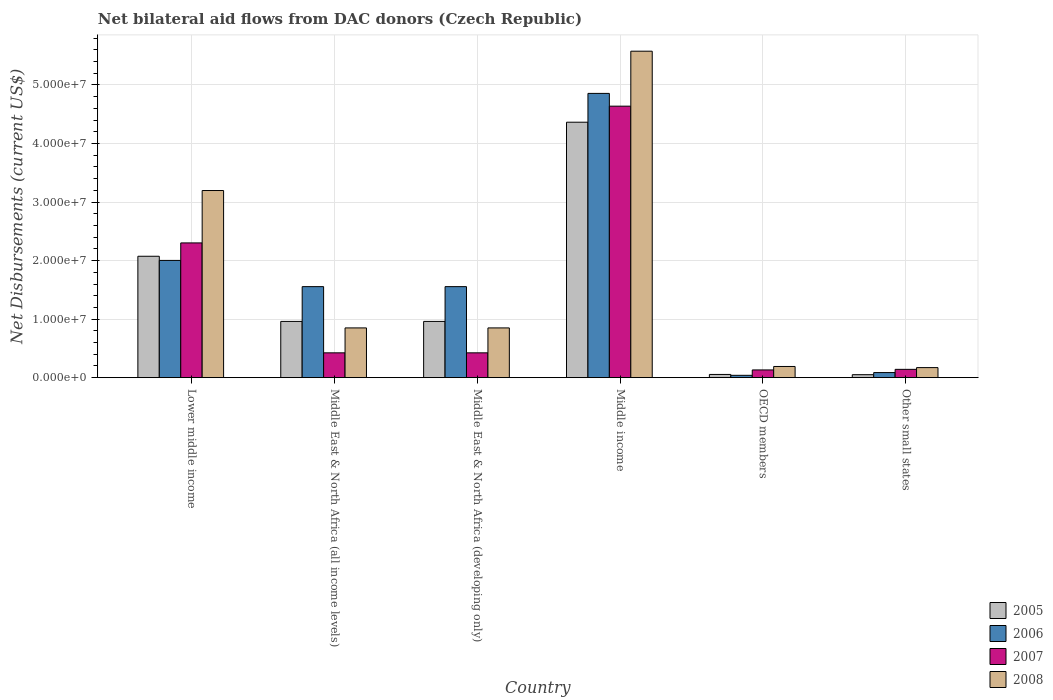How many different coloured bars are there?
Provide a succinct answer. 4. Are the number of bars per tick equal to the number of legend labels?
Your answer should be compact. Yes. Are the number of bars on each tick of the X-axis equal?
Make the answer very short. Yes. How many bars are there on the 5th tick from the right?
Offer a very short reply. 4. What is the label of the 2nd group of bars from the left?
Your response must be concise. Middle East & North Africa (all income levels). In how many cases, is the number of bars for a given country not equal to the number of legend labels?
Offer a very short reply. 0. What is the net bilateral aid flows in 2008 in Lower middle income?
Give a very brief answer. 3.20e+07. Across all countries, what is the maximum net bilateral aid flows in 2008?
Provide a succinct answer. 5.58e+07. Across all countries, what is the minimum net bilateral aid flows in 2006?
Your answer should be compact. 4.00e+05. In which country was the net bilateral aid flows in 2007 maximum?
Keep it short and to the point. Middle income. In which country was the net bilateral aid flows in 2007 minimum?
Give a very brief answer. OECD members. What is the total net bilateral aid flows in 2008 in the graph?
Your response must be concise. 1.08e+08. What is the difference between the net bilateral aid flows in 2007 in Middle East & North Africa (all income levels) and that in Middle East & North Africa (developing only)?
Keep it short and to the point. 0. What is the difference between the net bilateral aid flows in 2005 in Middle East & North Africa (all income levels) and the net bilateral aid flows in 2008 in Lower middle income?
Your response must be concise. -2.24e+07. What is the average net bilateral aid flows in 2005 per country?
Provide a succinct answer. 1.41e+07. What is the difference between the net bilateral aid flows of/in 2008 and net bilateral aid flows of/in 2005 in OECD members?
Provide a short and direct response. 1.36e+06. What is the ratio of the net bilateral aid flows in 2005 in Lower middle income to that in OECD members?
Your answer should be very brief. 37.71. Is the net bilateral aid flows in 2007 in Middle East & North Africa (all income levels) less than that in OECD members?
Your answer should be compact. No. Is the difference between the net bilateral aid flows in 2008 in Lower middle income and Middle East & North Africa (developing only) greater than the difference between the net bilateral aid flows in 2005 in Lower middle income and Middle East & North Africa (developing only)?
Offer a very short reply. Yes. What is the difference between the highest and the second highest net bilateral aid flows in 2008?
Ensure brevity in your answer.  4.73e+07. What is the difference between the highest and the lowest net bilateral aid flows in 2008?
Your answer should be very brief. 5.40e+07. In how many countries, is the net bilateral aid flows in 2005 greater than the average net bilateral aid flows in 2005 taken over all countries?
Provide a succinct answer. 2. Is it the case that in every country, the sum of the net bilateral aid flows in 2006 and net bilateral aid flows in 2007 is greater than the sum of net bilateral aid flows in 2008 and net bilateral aid flows in 2005?
Offer a very short reply. No. What does the 1st bar from the right in Lower middle income represents?
Offer a very short reply. 2008. Is it the case that in every country, the sum of the net bilateral aid flows in 2005 and net bilateral aid flows in 2007 is greater than the net bilateral aid flows in 2006?
Keep it short and to the point. No. Are all the bars in the graph horizontal?
Provide a short and direct response. No. How many countries are there in the graph?
Ensure brevity in your answer.  6. What is the difference between two consecutive major ticks on the Y-axis?
Ensure brevity in your answer.  1.00e+07. Are the values on the major ticks of Y-axis written in scientific E-notation?
Your response must be concise. Yes. Does the graph contain any zero values?
Offer a terse response. No. Does the graph contain grids?
Keep it short and to the point. Yes. Where does the legend appear in the graph?
Keep it short and to the point. Bottom right. How many legend labels are there?
Provide a short and direct response. 4. How are the legend labels stacked?
Your answer should be very brief. Vertical. What is the title of the graph?
Your answer should be very brief. Net bilateral aid flows from DAC donors (Czech Republic). Does "1996" appear as one of the legend labels in the graph?
Your answer should be compact. No. What is the label or title of the Y-axis?
Make the answer very short. Net Disbursements (current US$). What is the Net Disbursements (current US$) of 2005 in Lower middle income?
Offer a terse response. 2.07e+07. What is the Net Disbursements (current US$) in 2006 in Lower middle income?
Your answer should be compact. 2.00e+07. What is the Net Disbursements (current US$) in 2007 in Lower middle income?
Provide a short and direct response. 2.30e+07. What is the Net Disbursements (current US$) in 2008 in Lower middle income?
Make the answer very short. 3.20e+07. What is the Net Disbursements (current US$) of 2005 in Middle East & North Africa (all income levels)?
Give a very brief answer. 9.61e+06. What is the Net Disbursements (current US$) of 2006 in Middle East & North Africa (all income levels)?
Your answer should be very brief. 1.56e+07. What is the Net Disbursements (current US$) of 2007 in Middle East & North Africa (all income levels)?
Give a very brief answer. 4.24e+06. What is the Net Disbursements (current US$) of 2008 in Middle East & North Africa (all income levels)?
Your answer should be compact. 8.50e+06. What is the Net Disbursements (current US$) of 2005 in Middle East & North Africa (developing only)?
Your answer should be very brief. 9.61e+06. What is the Net Disbursements (current US$) of 2006 in Middle East & North Africa (developing only)?
Provide a short and direct response. 1.56e+07. What is the Net Disbursements (current US$) of 2007 in Middle East & North Africa (developing only)?
Your answer should be compact. 4.24e+06. What is the Net Disbursements (current US$) of 2008 in Middle East & North Africa (developing only)?
Your answer should be very brief. 8.50e+06. What is the Net Disbursements (current US$) in 2005 in Middle income?
Your answer should be very brief. 4.36e+07. What is the Net Disbursements (current US$) in 2006 in Middle income?
Offer a terse response. 4.86e+07. What is the Net Disbursements (current US$) of 2007 in Middle income?
Make the answer very short. 4.64e+07. What is the Net Disbursements (current US$) in 2008 in Middle income?
Make the answer very short. 5.58e+07. What is the Net Disbursements (current US$) of 2005 in OECD members?
Provide a short and direct response. 5.50e+05. What is the Net Disbursements (current US$) in 2007 in OECD members?
Your answer should be very brief. 1.32e+06. What is the Net Disbursements (current US$) in 2008 in OECD members?
Keep it short and to the point. 1.91e+06. What is the Net Disbursements (current US$) in 2005 in Other small states?
Offer a terse response. 5.10e+05. What is the Net Disbursements (current US$) of 2006 in Other small states?
Give a very brief answer. 8.70e+05. What is the Net Disbursements (current US$) of 2007 in Other small states?
Ensure brevity in your answer.  1.42e+06. What is the Net Disbursements (current US$) of 2008 in Other small states?
Your response must be concise. 1.72e+06. Across all countries, what is the maximum Net Disbursements (current US$) of 2005?
Keep it short and to the point. 4.36e+07. Across all countries, what is the maximum Net Disbursements (current US$) of 2006?
Your response must be concise. 4.86e+07. Across all countries, what is the maximum Net Disbursements (current US$) of 2007?
Ensure brevity in your answer.  4.64e+07. Across all countries, what is the maximum Net Disbursements (current US$) of 2008?
Give a very brief answer. 5.58e+07. Across all countries, what is the minimum Net Disbursements (current US$) in 2005?
Your answer should be very brief. 5.10e+05. Across all countries, what is the minimum Net Disbursements (current US$) of 2006?
Offer a very short reply. 4.00e+05. Across all countries, what is the minimum Net Disbursements (current US$) of 2007?
Give a very brief answer. 1.32e+06. Across all countries, what is the minimum Net Disbursements (current US$) of 2008?
Your answer should be very brief. 1.72e+06. What is the total Net Disbursements (current US$) of 2005 in the graph?
Offer a terse response. 8.47e+07. What is the total Net Disbursements (current US$) of 2006 in the graph?
Your answer should be compact. 1.01e+08. What is the total Net Disbursements (current US$) of 2007 in the graph?
Make the answer very short. 8.06e+07. What is the total Net Disbursements (current US$) of 2008 in the graph?
Your response must be concise. 1.08e+08. What is the difference between the Net Disbursements (current US$) in 2005 in Lower middle income and that in Middle East & North Africa (all income levels)?
Your response must be concise. 1.11e+07. What is the difference between the Net Disbursements (current US$) of 2006 in Lower middle income and that in Middle East & North Africa (all income levels)?
Provide a short and direct response. 4.48e+06. What is the difference between the Net Disbursements (current US$) in 2007 in Lower middle income and that in Middle East & North Africa (all income levels)?
Ensure brevity in your answer.  1.88e+07. What is the difference between the Net Disbursements (current US$) in 2008 in Lower middle income and that in Middle East & North Africa (all income levels)?
Offer a terse response. 2.35e+07. What is the difference between the Net Disbursements (current US$) in 2005 in Lower middle income and that in Middle East & North Africa (developing only)?
Your response must be concise. 1.11e+07. What is the difference between the Net Disbursements (current US$) of 2006 in Lower middle income and that in Middle East & North Africa (developing only)?
Make the answer very short. 4.48e+06. What is the difference between the Net Disbursements (current US$) in 2007 in Lower middle income and that in Middle East & North Africa (developing only)?
Give a very brief answer. 1.88e+07. What is the difference between the Net Disbursements (current US$) in 2008 in Lower middle income and that in Middle East & North Africa (developing only)?
Your answer should be very brief. 2.35e+07. What is the difference between the Net Disbursements (current US$) in 2005 in Lower middle income and that in Middle income?
Your answer should be compact. -2.29e+07. What is the difference between the Net Disbursements (current US$) of 2006 in Lower middle income and that in Middle income?
Your answer should be compact. -2.85e+07. What is the difference between the Net Disbursements (current US$) in 2007 in Lower middle income and that in Middle income?
Provide a succinct answer. -2.34e+07. What is the difference between the Net Disbursements (current US$) in 2008 in Lower middle income and that in Middle income?
Offer a terse response. -2.38e+07. What is the difference between the Net Disbursements (current US$) in 2005 in Lower middle income and that in OECD members?
Your answer should be very brief. 2.02e+07. What is the difference between the Net Disbursements (current US$) of 2006 in Lower middle income and that in OECD members?
Give a very brief answer. 1.96e+07. What is the difference between the Net Disbursements (current US$) of 2007 in Lower middle income and that in OECD members?
Provide a succinct answer. 2.17e+07. What is the difference between the Net Disbursements (current US$) of 2008 in Lower middle income and that in OECD members?
Give a very brief answer. 3.01e+07. What is the difference between the Net Disbursements (current US$) of 2005 in Lower middle income and that in Other small states?
Keep it short and to the point. 2.02e+07. What is the difference between the Net Disbursements (current US$) in 2006 in Lower middle income and that in Other small states?
Offer a very short reply. 1.92e+07. What is the difference between the Net Disbursements (current US$) of 2007 in Lower middle income and that in Other small states?
Make the answer very short. 2.16e+07. What is the difference between the Net Disbursements (current US$) of 2008 in Lower middle income and that in Other small states?
Provide a short and direct response. 3.02e+07. What is the difference between the Net Disbursements (current US$) of 2005 in Middle East & North Africa (all income levels) and that in Middle East & North Africa (developing only)?
Your answer should be compact. 0. What is the difference between the Net Disbursements (current US$) of 2006 in Middle East & North Africa (all income levels) and that in Middle East & North Africa (developing only)?
Your answer should be very brief. 0. What is the difference between the Net Disbursements (current US$) in 2007 in Middle East & North Africa (all income levels) and that in Middle East & North Africa (developing only)?
Make the answer very short. 0. What is the difference between the Net Disbursements (current US$) of 2008 in Middle East & North Africa (all income levels) and that in Middle East & North Africa (developing only)?
Your answer should be very brief. 0. What is the difference between the Net Disbursements (current US$) of 2005 in Middle East & North Africa (all income levels) and that in Middle income?
Your response must be concise. -3.40e+07. What is the difference between the Net Disbursements (current US$) in 2006 in Middle East & North Africa (all income levels) and that in Middle income?
Your response must be concise. -3.30e+07. What is the difference between the Net Disbursements (current US$) of 2007 in Middle East & North Africa (all income levels) and that in Middle income?
Provide a short and direct response. -4.21e+07. What is the difference between the Net Disbursements (current US$) of 2008 in Middle East & North Africa (all income levels) and that in Middle income?
Ensure brevity in your answer.  -4.73e+07. What is the difference between the Net Disbursements (current US$) of 2005 in Middle East & North Africa (all income levels) and that in OECD members?
Offer a terse response. 9.06e+06. What is the difference between the Net Disbursements (current US$) in 2006 in Middle East & North Africa (all income levels) and that in OECD members?
Provide a short and direct response. 1.52e+07. What is the difference between the Net Disbursements (current US$) of 2007 in Middle East & North Africa (all income levels) and that in OECD members?
Your answer should be compact. 2.92e+06. What is the difference between the Net Disbursements (current US$) of 2008 in Middle East & North Africa (all income levels) and that in OECD members?
Provide a short and direct response. 6.59e+06. What is the difference between the Net Disbursements (current US$) in 2005 in Middle East & North Africa (all income levels) and that in Other small states?
Your answer should be very brief. 9.10e+06. What is the difference between the Net Disbursements (current US$) in 2006 in Middle East & North Africa (all income levels) and that in Other small states?
Give a very brief answer. 1.47e+07. What is the difference between the Net Disbursements (current US$) in 2007 in Middle East & North Africa (all income levels) and that in Other small states?
Ensure brevity in your answer.  2.82e+06. What is the difference between the Net Disbursements (current US$) in 2008 in Middle East & North Africa (all income levels) and that in Other small states?
Give a very brief answer. 6.78e+06. What is the difference between the Net Disbursements (current US$) of 2005 in Middle East & North Africa (developing only) and that in Middle income?
Your answer should be compact. -3.40e+07. What is the difference between the Net Disbursements (current US$) of 2006 in Middle East & North Africa (developing only) and that in Middle income?
Provide a short and direct response. -3.30e+07. What is the difference between the Net Disbursements (current US$) of 2007 in Middle East & North Africa (developing only) and that in Middle income?
Your answer should be compact. -4.21e+07. What is the difference between the Net Disbursements (current US$) in 2008 in Middle East & North Africa (developing only) and that in Middle income?
Your response must be concise. -4.73e+07. What is the difference between the Net Disbursements (current US$) of 2005 in Middle East & North Africa (developing only) and that in OECD members?
Your answer should be very brief. 9.06e+06. What is the difference between the Net Disbursements (current US$) in 2006 in Middle East & North Africa (developing only) and that in OECD members?
Keep it short and to the point. 1.52e+07. What is the difference between the Net Disbursements (current US$) of 2007 in Middle East & North Africa (developing only) and that in OECD members?
Provide a short and direct response. 2.92e+06. What is the difference between the Net Disbursements (current US$) in 2008 in Middle East & North Africa (developing only) and that in OECD members?
Ensure brevity in your answer.  6.59e+06. What is the difference between the Net Disbursements (current US$) of 2005 in Middle East & North Africa (developing only) and that in Other small states?
Offer a terse response. 9.10e+06. What is the difference between the Net Disbursements (current US$) in 2006 in Middle East & North Africa (developing only) and that in Other small states?
Provide a short and direct response. 1.47e+07. What is the difference between the Net Disbursements (current US$) of 2007 in Middle East & North Africa (developing only) and that in Other small states?
Your response must be concise. 2.82e+06. What is the difference between the Net Disbursements (current US$) in 2008 in Middle East & North Africa (developing only) and that in Other small states?
Your response must be concise. 6.78e+06. What is the difference between the Net Disbursements (current US$) in 2005 in Middle income and that in OECD members?
Your answer should be compact. 4.31e+07. What is the difference between the Net Disbursements (current US$) in 2006 in Middle income and that in OECD members?
Provide a succinct answer. 4.82e+07. What is the difference between the Net Disbursements (current US$) of 2007 in Middle income and that in OECD members?
Offer a terse response. 4.51e+07. What is the difference between the Net Disbursements (current US$) in 2008 in Middle income and that in OECD members?
Give a very brief answer. 5.39e+07. What is the difference between the Net Disbursements (current US$) of 2005 in Middle income and that in Other small states?
Provide a succinct answer. 4.31e+07. What is the difference between the Net Disbursements (current US$) of 2006 in Middle income and that in Other small states?
Ensure brevity in your answer.  4.77e+07. What is the difference between the Net Disbursements (current US$) in 2007 in Middle income and that in Other small states?
Give a very brief answer. 4.50e+07. What is the difference between the Net Disbursements (current US$) of 2008 in Middle income and that in Other small states?
Ensure brevity in your answer.  5.40e+07. What is the difference between the Net Disbursements (current US$) of 2006 in OECD members and that in Other small states?
Offer a terse response. -4.70e+05. What is the difference between the Net Disbursements (current US$) of 2007 in OECD members and that in Other small states?
Your answer should be compact. -1.00e+05. What is the difference between the Net Disbursements (current US$) in 2008 in OECD members and that in Other small states?
Offer a terse response. 1.90e+05. What is the difference between the Net Disbursements (current US$) of 2005 in Lower middle income and the Net Disbursements (current US$) of 2006 in Middle East & North Africa (all income levels)?
Your answer should be very brief. 5.19e+06. What is the difference between the Net Disbursements (current US$) in 2005 in Lower middle income and the Net Disbursements (current US$) in 2007 in Middle East & North Africa (all income levels)?
Offer a terse response. 1.65e+07. What is the difference between the Net Disbursements (current US$) in 2005 in Lower middle income and the Net Disbursements (current US$) in 2008 in Middle East & North Africa (all income levels)?
Make the answer very short. 1.22e+07. What is the difference between the Net Disbursements (current US$) in 2006 in Lower middle income and the Net Disbursements (current US$) in 2007 in Middle East & North Africa (all income levels)?
Your response must be concise. 1.58e+07. What is the difference between the Net Disbursements (current US$) in 2006 in Lower middle income and the Net Disbursements (current US$) in 2008 in Middle East & North Africa (all income levels)?
Ensure brevity in your answer.  1.15e+07. What is the difference between the Net Disbursements (current US$) of 2007 in Lower middle income and the Net Disbursements (current US$) of 2008 in Middle East & North Africa (all income levels)?
Provide a succinct answer. 1.45e+07. What is the difference between the Net Disbursements (current US$) of 2005 in Lower middle income and the Net Disbursements (current US$) of 2006 in Middle East & North Africa (developing only)?
Provide a succinct answer. 5.19e+06. What is the difference between the Net Disbursements (current US$) of 2005 in Lower middle income and the Net Disbursements (current US$) of 2007 in Middle East & North Africa (developing only)?
Provide a short and direct response. 1.65e+07. What is the difference between the Net Disbursements (current US$) in 2005 in Lower middle income and the Net Disbursements (current US$) in 2008 in Middle East & North Africa (developing only)?
Your answer should be compact. 1.22e+07. What is the difference between the Net Disbursements (current US$) in 2006 in Lower middle income and the Net Disbursements (current US$) in 2007 in Middle East & North Africa (developing only)?
Keep it short and to the point. 1.58e+07. What is the difference between the Net Disbursements (current US$) of 2006 in Lower middle income and the Net Disbursements (current US$) of 2008 in Middle East & North Africa (developing only)?
Make the answer very short. 1.15e+07. What is the difference between the Net Disbursements (current US$) of 2007 in Lower middle income and the Net Disbursements (current US$) of 2008 in Middle East & North Africa (developing only)?
Your response must be concise. 1.45e+07. What is the difference between the Net Disbursements (current US$) of 2005 in Lower middle income and the Net Disbursements (current US$) of 2006 in Middle income?
Ensure brevity in your answer.  -2.78e+07. What is the difference between the Net Disbursements (current US$) in 2005 in Lower middle income and the Net Disbursements (current US$) in 2007 in Middle income?
Your response must be concise. -2.56e+07. What is the difference between the Net Disbursements (current US$) of 2005 in Lower middle income and the Net Disbursements (current US$) of 2008 in Middle income?
Offer a very short reply. -3.50e+07. What is the difference between the Net Disbursements (current US$) in 2006 in Lower middle income and the Net Disbursements (current US$) in 2007 in Middle income?
Make the answer very short. -2.64e+07. What is the difference between the Net Disbursements (current US$) of 2006 in Lower middle income and the Net Disbursements (current US$) of 2008 in Middle income?
Make the answer very short. -3.57e+07. What is the difference between the Net Disbursements (current US$) of 2007 in Lower middle income and the Net Disbursements (current US$) of 2008 in Middle income?
Your response must be concise. -3.28e+07. What is the difference between the Net Disbursements (current US$) in 2005 in Lower middle income and the Net Disbursements (current US$) in 2006 in OECD members?
Offer a terse response. 2.03e+07. What is the difference between the Net Disbursements (current US$) in 2005 in Lower middle income and the Net Disbursements (current US$) in 2007 in OECD members?
Offer a terse response. 1.94e+07. What is the difference between the Net Disbursements (current US$) of 2005 in Lower middle income and the Net Disbursements (current US$) of 2008 in OECD members?
Provide a short and direct response. 1.88e+07. What is the difference between the Net Disbursements (current US$) of 2006 in Lower middle income and the Net Disbursements (current US$) of 2007 in OECD members?
Your response must be concise. 1.87e+07. What is the difference between the Net Disbursements (current US$) of 2006 in Lower middle income and the Net Disbursements (current US$) of 2008 in OECD members?
Make the answer very short. 1.81e+07. What is the difference between the Net Disbursements (current US$) of 2007 in Lower middle income and the Net Disbursements (current US$) of 2008 in OECD members?
Ensure brevity in your answer.  2.11e+07. What is the difference between the Net Disbursements (current US$) in 2005 in Lower middle income and the Net Disbursements (current US$) in 2006 in Other small states?
Provide a short and direct response. 1.99e+07. What is the difference between the Net Disbursements (current US$) in 2005 in Lower middle income and the Net Disbursements (current US$) in 2007 in Other small states?
Ensure brevity in your answer.  1.93e+07. What is the difference between the Net Disbursements (current US$) in 2005 in Lower middle income and the Net Disbursements (current US$) in 2008 in Other small states?
Your answer should be compact. 1.90e+07. What is the difference between the Net Disbursements (current US$) of 2006 in Lower middle income and the Net Disbursements (current US$) of 2007 in Other small states?
Your answer should be very brief. 1.86e+07. What is the difference between the Net Disbursements (current US$) of 2006 in Lower middle income and the Net Disbursements (current US$) of 2008 in Other small states?
Your answer should be very brief. 1.83e+07. What is the difference between the Net Disbursements (current US$) of 2007 in Lower middle income and the Net Disbursements (current US$) of 2008 in Other small states?
Provide a short and direct response. 2.13e+07. What is the difference between the Net Disbursements (current US$) in 2005 in Middle East & North Africa (all income levels) and the Net Disbursements (current US$) in 2006 in Middle East & North Africa (developing only)?
Offer a terse response. -5.94e+06. What is the difference between the Net Disbursements (current US$) of 2005 in Middle East & North Africa (all income levels) and the Net Disbursements (current US$) of 2007 in Middle East & North Africa (developing only)?
Give a very brief answer. 5.37e+06. What is the difference between the Net Disbursements (current US$) in 2005 in Middle East & North Africa (all income levels) and the Net Disbursements (current US$) in 2008 in Middle East & North Africa (developing only)?
Your answer should be very brief. 1.11e+06. What is the difference between the Net Disbursements (current US$) of 2006 in Middle East & North Africa (all income levels) and the Net Disbursements (current US$) of 2007 in Middle East & North Africa (developing only)?
Make the answer very short. 1.13e+07. What is the difference between the Net Disbursements (current US$) in 2006 in Middle East & North Africa (all income levels) and the Net Disbursements (current US$) in 2008 in Middle East & North Africa (developing only)?
Ensure brevity in your answer.  7.05e+06. What is the difference between the Net Disbursements (current US$) in 2007 in Middle East & North Africa (all income levels) and the Net Disbursements (current US$) in 2008 in Middle East & North Africa (developing only)?
Keep it short and to the point. -4.26e+06. What is the difference between the Net Disbursements (current US$) of 2005 in Middle East & North Africa (all income levels) and the Net Disbursements (current US$) of 2006 in Middle income?
Give a very brief answer. -3.90e+07. What is the difference between the Net Disbursements (current US$) of 2005 in Middle East & North Africa (all income levels) and the Net Disbursements (current US$) of 2007 in Middle income?
Offer a terse response. -3.68e+07. What is the difference between the Net Disbursements (current US$) in 2005 in Middle East & North Africa (all income levels) and the Net Disbursements (current US$) in 2008 in Middle income?
Make the answer very short. -4.62e+07. What is the difference between the Net Disbursements (current US$) of 2006 in Middle East & North Africa (all income levels) and the Net Disbursements (current US$) of 2007 in Middle income?
Provide a short and direct response. -3.08e+07. What is the difference between the Net Disbursements (current US$) of 2006 in Middle East & North Africa (all income levels) and the Net Disbursements (current US$) of 2008 in Middle income?
Provide a succinct answer. -4.02e+07. What is the difference between the Net Disbursements (current US$) in 2007 in Middle East & North Africa (all income levels) and the Net Disbursements (current US$) in 2008 in Middle income?
Provide a short and direct response. -5.15e+07. What is the difference between the Net Disbursements (current US$) of 2005 in Middle East & North Africa (all income levels) and the Net Disbursements (current US$) of 2006 in OECD members?
Provide a short and direct response. 9.21e+06. What is the difference between the Net Disbursements (current US$) in 2005 in Middle East & North Africa (all income levels) and the Net Disbursements (current US$) in 2007 in OECD members?
Your answer should be very brief. 8.29e+06. What is the difference between the Net Disbursements (current US$) of 2005 in Middle East & North Africa (all income levels) and the Net Disbursements (current US$) of 2008 in OECD members?
Your response must be concise. 7.70e+06. What is the difference between the Net Disbursements (current US$) of 2006 in Middle East & North Africa (all income levels) and the Net Disbursements (current US$) of 2007 in OECD members?
Provide a succinct answer. 1.42e+07. What is the difference between the Net Disbursements (current US$) in 2006 in Middle East & North Africa (all income levels) and the Net Disbursements (current US$) in 2008 in OECD members?
Provide a short and direct response. 1.36e+07. What is the difference between the Net Disbursements (current US$) of 2007 in Middle East & North Africa (all income levels) and the Net Disbursements (current US$) of 2008 in OECD members?
Make the answer very short. 2.33e+06. What is the difference between the Net Disbursements (current US$) in 2005 in Middle East & North Africa (all income levels) and the Net Disbursements (current US$) in 2006 in Other small states?
Ensure brevity in your answer.  8.74e+06. What is the difference between the Net Disbursements (current US$) of 2005 in Middle East & North Africa (all income levels) and the Net Disbursements (current US$) of 2007 in Other small states?
Make the answer very short. 8.19e+06. What is the difference between the Net Disbursements (current US$) in 2005 in Middle East & North Africa (all income levels) and the Net Disbursements (current US$) in 2008 in Other small states?
Your answer should be very brief. 7.89e+06. What is the difference between the Net Disbursements (current US$) of 2006 in Middle East & North Africa (all income levels) and the Net Disbursements (current US$) of 2007 in Other small states?
Provide a short and direct response. 1.41e+07. What is the difference between the Net Disbursements (current US$) in 2006 in Middle East & North Africa (all income levels) and the Net Disbursements (current US$) in 2008 in Other small states?
Your answer should be compact. 1.38e+07. What is the difference between the Net Disbursements (current US$) of 2007 in Middle East & North Africa (all income levels) and the Net Disbursements (current US$) of 2008 in Other small states?
Make the answer very short. 2.52e+06. What is the difference between the Net Disbursements (current US$) in 2005 in Middle East & North Africa (developing only) and the Net Disbursements (current US$) in 2006 in Middle income?
Provide a succinct answer. -3.90e+07. What is the difference between the Net Disbursements (current US$) of 2005 in Middle East & North Africa (developing only) and the Net Disbursements (current US$) of 2007 in Middle income?
Your answer should be very brief. -3.68e+07. What is the difference between the Net Disbursements (current US$) of 2005 in Middle East & North Africa (developing only) and the Net Disbursements (current US$) of 2008 in Middle income?
Offer a very short reply. -4.62e+07. What is the difference between the Net Disbursements (current US$) in 2006 in Middle East & North Africa (developing only) and the Net Disbursements (current US$) in 2007 in Middle income?
Provide a succinct answer. -3.08e+07. What is the difference between the Net Disbursements (current US$) in 2006 in Middle East & North Africa (developing only) and the Net Disbursements (current US$) in 2008 in Middle income?
Keep it short and to the point. -4.02e+07. What is the difference between the Net Disbursements (current US$) of 2007 in Middle East & North Africa (developing only) and the Net Disbursements (current US$) of 2008 in Middle income?
Your response must be concise. -5.15e+07. What is the difference between the Net Disbursements (current US$) of 2005 in Middle East & North Africa (developing only) and the Net Disbursements (current US$) of 2006 in OECD members?
Your answer should be very brief. 9.21e+06. What is the difference between the Net Disbursements (current US$) of 2005 in Middle East & North Africa (developing only) and the Net Disbursements (current US$) of 2007 in OECD members?
Your response must be concise. 8.29e+06. What is the difference between the Net Disbursements (current US$) in 2005 in Middle East & North Africa (developing only) and the Net Disbursements (current US$) in 2008 in OECD members?
Your answer should be compact. 7.70e+06. What is the difference between the Net Disbursements (current US$) of 2006 in Middle East & North Africa (developing only) and the Net Disbursements (current US$) of 2007 in OECD members?
Keep it short and to the point. 1.42e+07. What is the difference between the Net Disbursements (current US$) of 2006 in Middle East & North Africa (developing only) and the Net Disbursements (current US$) of 2008 in OECD members?
Make the answer very short. 1.36e+07. What is the difference between the Net Disbursements (current US$) of 2007 in Middle East & North Africa (developing only) and the Net Disbursements (current US$) of 2008 in OECD members?
Offer a very short reply. 2.33e+06. What is the difference between the Net Disbursements (current US$) in 2005 in Middle East & North Africa (developing only) and the Net Disbursements (current US$) in 2006 in Other small states?
Give a very brief answer. 8.74e+06. What is the difference between the Net Disbursements (current US$) of 2005 in Middle East & North Africa (developing only) and the Net Disbursements (current US$) of 2007 in Other small states?
Ensure brevity in your answer.  8.19e+06. What is the difference between the Net Disbursements (current US$) of 2005 in Middle East & North Africa (developing only) and the Net Disbursements (current US$) of 2008 in Other small states?
Provide a short and direct response. 7.89e+06. What is the difference between the Net Disbursements (current US$) of 2006 in Middle East & North Africa (developing only) and the Net Disbursements (current US$) of 2007 in Other small states?
Give a very brief answer. 1.41e+07. What is the difference between the Net Disbursements (current US$) in 2006 in Middle East & North Africa (developing only) and the Net Disbursements (current US$) in 2008 in Other small states?
Your response must be concise. 1.38e+07. What is the difference between the Net Disbursements (current US$) of 2007 in Middle East & North Africa (developing only) and the Net Disbursements (current US$) of 2008 in Other small states?
Provide a succinct answer. 2.52e+06. What is the difference between the Net Disbursements (current US$) of 2005 in Middle income and the Net Disbursements (current US$) of 2006 in OECD members?
Offer a very short reply. 4.32e+07. What is the difference between the Net Disbursements (current US$) in 2005 in Middle income and the Net Disbursements (current US$) in 2007 in OECD members?
Your answer should be compact. 4.23e+07. What is the difference between the Net Disbursements (current US$) in 2005 in Middle income and the Net Disbursements (current US$) in 2008 in OECD members?
Make the answer very short. 4.17e+07. What is the difference between the Net Disbursements (current US$) of 2006 in Middle income and the Net Disbursements (current US$) of 2007 in OECD members?
Offer a terse response. 4.72e+07. What is the difference between the Net Disbursements (current US$) in 2006 in Middle income and the Net Disbursements (current US$) in 2008 in OECD members?
Provide a short and direct response. 4.66e+07. What is the difference between the Net Disbursements (current US$) of 2007 in Middle income and the Net Disbursements (current US$) of 2008 in OECD members?
Offer a very short reply. 4.45e+07. What is the difference between the Net Disbursements (current US$) of 2005 in Middle income and the Net Disbursements (current US$) of 2006 in Other small states?
Your answer should be compact. 4.28e+07. What is the difference between the Net Disbursements (current US$) in 2005 in Middle income and the Net Disbursements (current US$) in 2007 in Other small states?
Offer a terse response. 4.22e+07. What is the difference between the Net Disbursements (current US$) of 2005 in Middle income and the Net Disbursements (current US$) of 2008 in Other small states?
Your answer should be very brief. 4.19e+07. What is the difference between the Net Disbursements (current US$) of 2006 in Middle income and the Net Disbursements (current US$) of 2007 in Other small states?
Your answer should be very brief. 4.71e+07. What is the difference between the Net Disbursements (current US$) in 2006 in Middle income and the Net Disbursements (current US$) in 2008 in Other small states?
Offer a very short reply. 4.68e+07. What is the difference between the Net Disbursements (current US$) in 2007 in Middle income and the Net Disbursements (current US$) in 2008 in Other small states?
Offer a very short reply. 4.47e+07. What is the difference between the Net Disbursements (current US$) in 2005 in OECD members and the Net Disbursements (current US$) in 2006 in Other small states?
Provide a short and direct response. -3.20e+05. What is the difference between the Net Disbursements (current US$) in 2005 in OECD members and the Net Disbursements (current US$) in 2007 in Other small states?
Provide a short and direct response. -8.70e+05. What is the difference between the Net Disbursements (current US$) of 2005 in OECD members and the Net Disbursements (current US$) of 2008 in Other small states?
Ensure brevity in your answer.  -1.17e+06. What is the difference between the Net Disbursements (current US$) in 2006 in OECD members and the Net Disbursements (current US$) in 2007 in Other small states?
Your answer should be compact. -1.02e+06. What is the difference between the Net Disbursements (current US$) of 2006 in OECD members and the Net Disbursements (current US$) of 2008 in Other small states?
Make the answer very short. -1.32e+06. What is the difference between the Net Disbursements (current US$) of 2007 in OECD members and the Net Disbursements (current US$) of 2008 in Other small states?
Your answer should be very brief. -4.00e+05. What is the average Net Disbursements (current US$) in 2005 per country?
Give a very brief answer. 1.41e+07. What is the average Net Disbursements (current US$) of 2006 per country?
Offer a very short reply. 1.68e+07. What is the average Net Disbursements (current US$) in 2007 per country?
Ensure brevity in your answer.  1.34e+07. What is the average Net Disbursements (current US$) of 2008 per country?
Your answer should be compact. 1.81e+07. What is the difference between the Net Disbursements (current US$) in 2005 and Net Disbursements (current US$) in 2006 in Lower middle income?
Offer a very short reply. 7.10e+05. What is the difference between the Net Disbursements (current US$) of 2005 and Net Disbursements (current US$) of 2007 in Lower middle income?
Your answer should be compact. -2.28e+06. What is the difference between the Net Disbursements (current US$) in 2005 and Net Disbursements (current US$) in 2008 in Lower middle income?
Your answer should be compact. -1.12e+07. What is the difference between the Net Disbursements (current US$) of 2006 and Net Disbursements (current US$) of 2007 in Lower middle income?
Your response must be concise. -2.99e+06. What is the difference between the Net Disbursements (current US$) in 2006 and Net Disbursements (current US$) in 2008 in Lower middle income?
Keep it short and to the point. -1.19e+07. What is the difference between the Net Disbursements (current US$) in 2007 and Net Disbursements (current US$) in 2008 in Lower middle income?
Provide a succinct answer. -8.95e+06. What is the difference between the Net Disbursements (current US$) of 2005 and Net Disbursements (current US$) of 2006 in Middle East & North Africa (all income levels)?
Your answer should be very brief. -5.94e+06. What is the difference between the Net Disbursements (current US$) in 2005 and Net Disbursements (current US$) in 2007 in Middle East & North Africa (all income levels)?
Your answer should be compact. 5.37e+06. What is the difference between the Net Disbursements (current US$) in 2005 and Net Disbursements (current US$) in 2008 in Middle East & North Africa (all income levels)?
Your answer should be compact. 1.11e+06. What is the difference between the Net Disbursements (current US$) of 2006 and Net Disbursements (current US$) of 2007 in Middle East & North Africa (all income levels)?
Give a very brief answer. 1.13e+07. What is the difference between the Net Disbursements (current US$) of 2006 and Net Disbursements (current US$) of 2008 in Middle East & North Africa (all income levels)?
Your response must be concise. 7.05e+06. What is the difference between the Net Disbursements (current US$) of 2007 and Net Disbursements (current US$) of 2008 in Middle East & North Africa (all income levels)?
Your answer should be very brief. -4.26e+06. What is the difference between the Net Disbursements (current US$) of 2005 and Net Disbursements (current US$) of 2006 in Middle East & North Africa (developing only)?
Offer a very short reply. -5.94e+06. What is the difference between the Net Disbursements (current US$) in 2005 and Net Disbursements (current US$) in 2007 in Middle East & North Africa (developing only)?
Keep it short and to the point. 5.37e+06. What is the difference between the Net Disbursements (current US$) of 2005 and Net Disbursements (current US$) of 2008 in Middle East & North Africa (developing only)?
Give a very brief answer. 1.11e+06. What is the difference between the Net Disbursements (current US$) in 2006 and Net Disbursements (current US$) in 2007 in Middle East & North Africa (developing only)?
Your answer should be compact. 1.13e+07. What is the difference between the Net Disbursements (current US$) in 2006 and Net Disbursements (current US$) in 2008 in Middle East & North Africa (developing only)?
Your answer should be very brief. 7.05e+06. What is the difference between the Net Disbursements (current US$) of 2007 and Net Disbursements (current US$) of 2008 in Middle East & North Africa (developing only)?
Offer a terse response. -4.26e+06. What is the difference between the Net Disbursements (current US$) of 2005 and Net Disbursements (current US$) of 2006 in Middle income?
Provide a short and direct response. -4.92e+06. What is the difference between the Net Disbursements (current US$) of 2005 and Net Disbursements (current US$) of 2007 in Middle income?
Ensure brevity in your answer.  -2.74e+06. What is the difference between the Net Disbursements (current US$) in 2005 and Net Disbursements (current US$) in 2008 in Middle income?
Give a very brief answer. -1.21e+07. What is the difference between the Net Disbursements (current US$) in 2006 and Net Disbursements (current US$) in 2007 in Middle income?
Provide a succinct answer. 2.18e+06. What is the difference between the Net Disbursements (current US$) in 2006 and Net Disbursements (current US$) in 2008 in Middle income?
Make the answer very short. -7.21e+06. What is the difference between the Net Disbursements (current US$) in 2007 and Net Disbursements (current US$) in 2008 in Middle income?
Ensure brevity in your answer.  -9.39e+06. What is the difference between the Net Disbursements (current US$) in 2005 and Net Disbursements (current US$) in 2007 in OECD members?
Offer a terse response. -7.70e+05. What is the difference between the Net Disbursements (current US$) of 2005 and Net Disbursements (current US$) of 2008 in OECD members?
Offer a terse response. -1.36e+06. What is the difference between the Net Disbursements (current US$) of 2006 and Net Disbursements (current US$) of 2007 in OECD members?
Offer a very short reply. -9.20e+05. What is the difference between the Net Disbursements (current US$) of 2006 and Net Disbursements (current US$) of 2008 in OECD members?
Ensure brevity in your answer.  -1.51e+06. What is the difference between the Net Disbursements (current US$) of 2007 and Net Disbursements (current US$) of 2008 in OECD members?
Make the answer very short. -5.90e+05. What is the difference between the Net Disbursements (current US$) of 2005 and Net Disbursements (current US$) of 2006 in Other small states?
Offer a very short reply. -3.60e+05. What is the difference between the Net Disbursements (current US$) in 2005 and Net Disbursements (current US$) in 2007 in Other small states?
Give a very brief answer. -9.10e+05. What is the difference between the Net Disbursements (current US$) in 2005 and Net Disbursements (current US$) in 2008 in Other small states?
Ensure brevity in your answer.  -1.21e+06. What is the difference between the Net Disbursements (current US$) in 2006 and Net Disbursements (current US$) in 2007 in Other small states?
Your answer should be compact. -5.50e+05. What is the difference between the Net Disbursements (current US$) in 2006 and Net Disbursements (current US$) in 2008 in Other small states?
Your answer should be very brief. -8.50e+05. What is the difference between the Net Disbursements (current US$) of 2007 and Net Disbursements (current US$) of 2008 in Other small states?
Offer a very short reply. -3.00e+05. What is the ratio of the Net Disbursements (current US$) in 2005 in Lower middle income to that in Middle East & North Africa (all income levels)?
Your answer should be very brief. 2.16. What is the ratio of the Net Disbursements (current US$) of 2006 in Lower middle income to that in Middle East & North Africa (all income levels)?
Provide a succinct answer. 1.29. What is the ratio of the Net Disbursements (current US$) of 2007 in Lower middle income to that in Middle East & North Africa (all income levels)?
Keep it short and to the point. 5.43. What is the ratio of the Net Disbursements (current US$) in 2008 in Lower middle income to that in Middle East & North Africa (all income levels)?
Give a very brief answer. 3.76. What is the ratio of the Net Disbursements (current US$) in 2005 in Lower middle income to that in Middle East & North Africa (developing only)?
Provide a short and direct response. 2.16. What is the ratio of the Net Disbursements (current US$) in 2006 in Lower middle income to that in Middle East & North Africa (developing only)?
Your answer should be very brief. 1.29. What is the ratio of the Net Disbursements (current US$) in 2007 in Lower middle income to that in Middle East & North Africa (developing only)?
Your answer should be very brief. 5.43. What is the ratio of the Net Disbursements (current US$) in 2008 in Lower middle income to that in Middle East & North Africa (developing only)?
Provide a succinct answer. 3.76. What is the ratio of the Net Disbursements (current US$) in 2005 in Lower middle income to that in Middle income?
Offer a terse response. 0.48. What is the ratio of the Net Disbursements (current US$) in 2006 in Lower middle income to that in Middle income?
Keep it short and to the point. 0.41. What is the ratio of the Net Disbursements (current US$) in 2007 in Lower middle income to that in Middle income?
Ensure brevity in your answer.  0.5. What is the ratio of the Net Disbursements (current US$) in 2008 in Lower middle income to that in Middle income?
Your answer should be very brief. 0.57. What is the ratio of the Net Disbursements (current US$) of 2005 in Lower middle income to that in OECD members?
Ensure brevity in your answer.  37.71. What is the ratio of the Net Disbursements (current US$) of 2006 in Lower middle income to that in OECD members?
Offer a terse response. 50.08. What is the ratio of the Net Disbursements (current US$) in 2007 in Lower middle income to that in OECD members?
Give a very brief answer. 17.44. What is the ratio of the Net Disbursements (current US$) in 2008 in Lower middle income to that in OECD members?
Ensure brevity in your answer.  16.74. What is the ratio of the Net Disbursements (current US$) of 2005 in Lower middle income to that in Other small states?
Your response must be concise. 40.67. What is the ratio of the Net Disbursements (current US$) in 2006 in Lower middle income to that in Other small states?
Give a very brief answer. 23.02. What is the ratio of the Net Disbursements (current US$) in 2007 in Lower middle income to that in Other small states?
Offer a very short reply. 16.21. What is the ratio of the Net Disbursements (current US$) in 2008 in Lower middle income to that in Other small states?
Your answer should be very brief. 18.59. What is the ratio of the Net Disbursements (current US$) of 2005 in Middle East & North Africa (all income levels) to that in Middle East & North Africa (developing only)?
Offer a terse response. 1. What is the ratio of the Net Disbursements (current US$) in 2006 in Middle East & North Africa (all income levels) to that in Middle East & North Africa (developing only)?
Your response must be concise. 1. What is the ratio of the Net Disbursements (current US$) in 2007 in Middle East & North Africa (all income levels) to that in Middle East & North Africa (developing only)?
Offer a very short reply. 1. What is the ratio of the Net Disbursements (current US$) of 2008 in Middle East & North Africa (all income levels) to that in Middle East & North Africa (developing only)?
Offer a very short reply. 1. What is the ratio of the Net Disbursements (current US$) in 2005 in Middle East & North Africa (all income levels) to that in Middle income?
Offer a terse response. 0.22. What is the ratio of the Net Disbursements (current US$) in 2006 in Middle East & North Africa (all income levels) to that in Middle income?
Ensure brevity in your answer.  0.32. What is the ratio of the Net Disbursements (current US$) of 2007 in Middle East & North Africa (all income levels) to that in Middle income?
Give a very brief answer. 0.09. What is the ratio of the Net Disbursements (current US$) of 2008 in Middle East & North Africa (all income levels) to that in Middle income?
Provide a succinct answer. 0.15. What is the ratio of the Net Disbursements (current US$) of 2005 in Middle East & North Africa (all income levels) to that in OECD members?
Offer a very short reply. 17.47. What is the ratio of the Net Disbursements (current US$) in 2006 in Middle East & North Africa (all income levels) to that in OECD members?
Your answer should be compact. 38.88. What is the ratio of the Net Disbursements (current US$) in 2007 in Middle East & North Africa (all income levels) to that in OECD members?
Your answer should be compact. 3.21. What is the ratio of the Net Disbursements (current US$) of 2008 in Middle East & North Africa (all income levels) to that in OECD members?
Your response must be concise. 4.45. What is the ratio of the Net Disbursements (current US$) of 2005 in Middle East & North Africa (all income levels) to that in Other small states?
Provide a short and direct response. 18.84. What is the ratio of the Net Disbursements (current US$) of 2006 in Middle East & North Africa (all income levels) to that in Other small states?
Make the answer very short. 17.87. What is the ratio of the Net Disbursements (current US$) of 2007 in Middle East & North Africa (all income levels) to that in Other small states?
Give a very brief answer. 2.99. What is the ratio of the Net Disbursements (current US$) in 2008 in Middle East & North Africa (all income levels) to that in Other small states?
Your answer should be very brief. 4.94. What is the ratio of the Net Disbursements (current US$) in 2005 in Middle East & North Africa (developing only) to that in Middle income?
Provide a short and direct response. 0.22. What is the ratio of the Net Disbursements (current US$) of 2006 in Middle East & North Africa (developing only) to that in Middle income?
Your answer should be compact. 0.32. What is the ratio of the Net Disbursements (current US$) of 2007 in Middle East & North Africa (developing only) to that in Middle income?
Your answer should be very brief. 0.09. What is the ratio of the Net Disbursements (current US$) in 2008 in Middle East & North Africa (developing only) to that in Middle income?
Your answer should be very brief. 0.15. What is the ratio of the Net Disbursements (current US$) in 2005 in Middle East & North Africa (developing only) to that in OECD members?
Your answer should be very brief. 17.47. What is the ratio of the Net Disbursements (current US$) of 2006 in Middle East & North Africa (developing only) to that in OECD members?
Your response must be concise. 38.88. What is the ratio of the Net Disbursements (current US$) in 2007 in Middle East & North Africa (developing only) to that in OECD members?
Give a very brief answer. 3.21. What is the ratio of the Net Disbursements (current US$) of 2008 in Middle East & North Africa (developing only) to that in OECD members?
Your answer should be very brief. 4.45. What is the ratio of the Net Disbursements (current US$) of 2005 in Middle East & North Africa (developing only) to that in Other small states?
Offer a terse response. 18.84. What is the ratio of the Net Disbursements (current US$) in 2006 in Middle East & North Africa (developing only) to that in Other small states?
Your response must be concise. 17.87. What is the ratio of the Net Disbursements (current US$) of 2007 in Middle East & North Africa (developing only) to that in Other small states?
Provide a succinct answer. 2.99. What is the ratio of the Net Disbursements (current US$) in 2008 in Middle East & North Africa (developing only) to that in Other small states?
Keep it short and to the point. 4.94. What is the ratio of the Net Disbursements (current US$) in 2005 in Middle income to that in OECD members?
Provide a succinct answer. 79.35. What is the ratio of the Net Disbursements (current US$) in 2006 in Middle income to that in OECD members?
Your response must be concise. 121.4. What is the ratio of the Net Disbursements (current US$) in 2007 in Middle income to that in OECD members?
Provide a short and direct response. 35.14. What is the ratio of the Net Disbursements (current US$) of 2008 in Middle income to that in OECD members?
Keep it short and to the point. 29.2. What is the ratio of the Net Disbursements (current US$) of 2005 in Middle income to that in Other small states?
Make the answer very short. 85.57. What is the ratio of the Net Disbursements (current US$) in 2006 in Middle income to that in Other small states?
Keep it short and to the point. 55.82. What is the ratio of the Net Disbursements (current US$) of 2007 in Middle income to that in Other small states?
Provide a short and direct response. 32.66. What is the ratio of the Net Disbursements (current US$) in 2008 in Middle income to that in Other small states?
Offer a terse response. 32.42. What is the ratio of the Net Disbursements (current US$) in 2005 in OECD members to that in Other small states?
Make the answer very short. 1.08. What is the ratio of the Net Disbursements (current US$) in 2006 in OECD members to that in Other small states?
Ensure brevity in your answer.  0.46. What is the ratio of the Net Disbursements (current US$) in 2007 in OECD members to that in Other small states?
Give a very brief answer. 0.93. What is the ratio of the Net Disbursements (current US$) of 2008 in OECD members to that in Other small states?
Provide a short and direct response. 1.11. What is the difference between the highest and the second highest Net Disbursements (current US$) of 2005?
Keep it short and to the point. 2.29e+07. What is the difference between the highest and the second highest Net Disbursements (current US$) of 2006?
Offer a terse response. 2.85e+07. What is the difference between the highest and the second highest Net Disbursements (current US$) of 2007?
Keep it short and to the point. 2.34e+07. What is the difference between the highest and the second highest Net Disbursements (current US$) in 2008?
Keep it short and to the point. 2.38e+07. What is the difference between the highest and the lowest Net Disbursements (current US$) in 2005?
Offer a very short reply. 4.31e+07. What is the difference between the highest and the lowest Net Disbursements (current US$) in 2006?
Give a very brief answer. 4.82e+07. What is the difference between the highest and the lowest Net Disbursements (current US$) of 2007?
Give a very brief answer. 4.51e+07. What is the difference between the highest and the lowest Net Disbursements (current US$) in 2008?
Provide a short and direct response. 5.40e+07. 